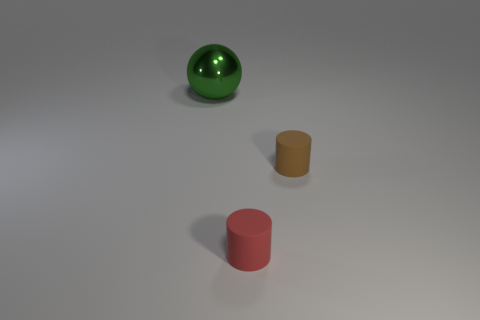Are there any other things that have the same size as the green thing?
Offer a very short reply. No. Is there any other thing that has the same shape as the large green shiny thing?
Provide a succinct answer. No. There is a thing to the right of the small cylinder on the left side of the brown rubber cylinder; what is its size?
Your answer should be compact. Small. There is a cylinder that is behind the tiny red matte object; what is its color?
Offer a terse response. Brown. Is there another big red matte object of the same shape as the large thing?
Provide a succinct answer. No. Are there fewer cylinders left of the metallic object than large green shiny objects that are in front of the brown rubber cylinder?
Ensure brevity in your answer.  No. What is the color of the big ball?
Your response must be concise. Green. Are there any tiny red cylinders behind the small cylinder that is to the right of the tiny red rubber thing?
Your answer should be very brief. No. How many brown matte cylinders are the same size as the green metal thing?
Your answer should be compact. 0. How many green shiny spheres are in front of the matte cylinder in front of the small rubber object that is behind the red thing?
Your response must be concise. 0. 